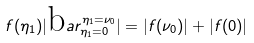<formula> <loc_0><loc_0><loc_500><loc_500>f ( \eta _ { 1 } ) | \text  bar _{\eta_{1}=0} ^ { \eta _ { 1 } = \nu _ { 0 } } | = | f ( \nu _ { 0 } ) | + | f ( 0 ) |</formula> 